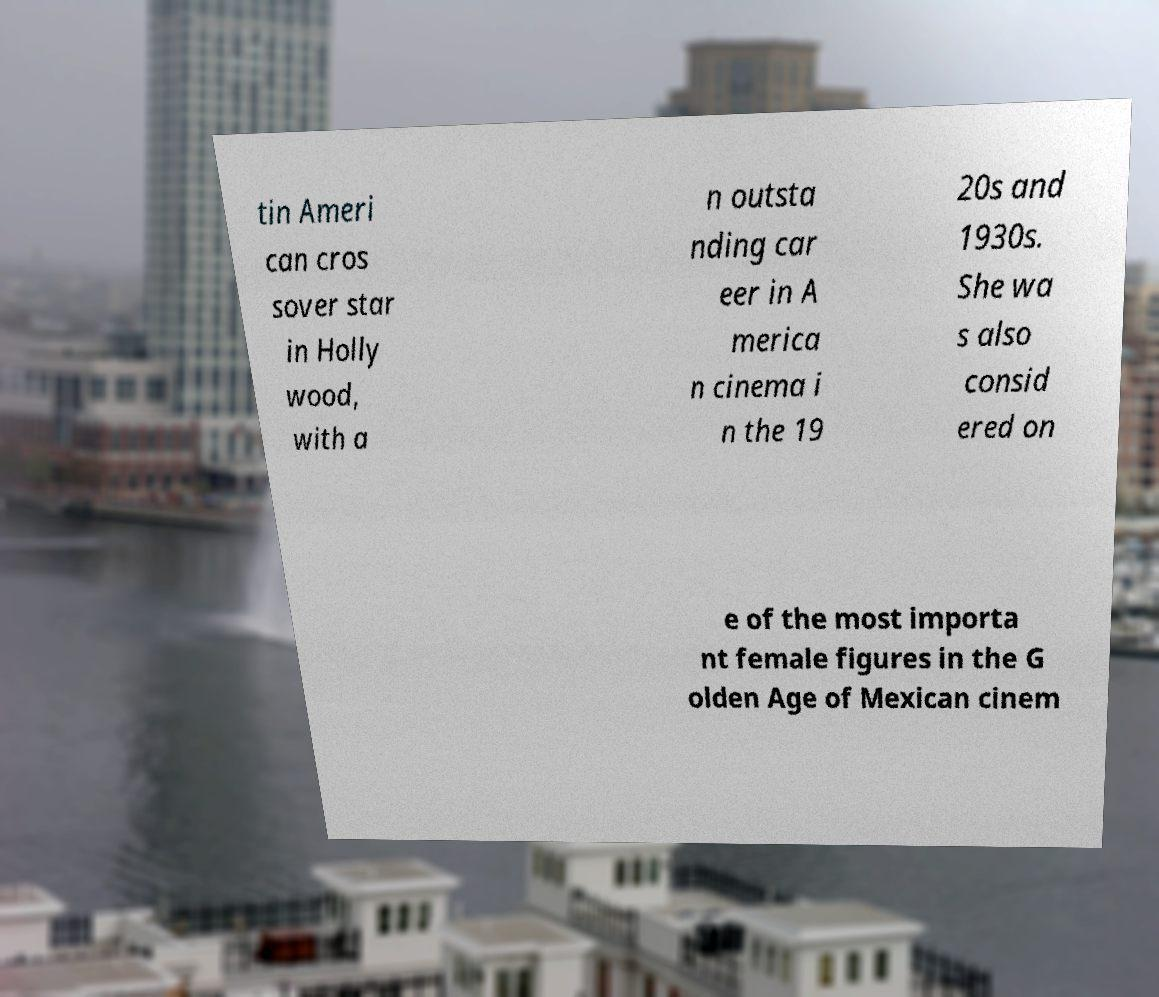Please identify and transcribe the text found in this image. tin Ameri can cros sover star in Holly wood, with a n outsta nding car eer in A merica n cinema i n the 19 20s and 1930s. She wa s also consid ered on e of the most importa nt female figures in the G olden Age of Mexican cinem 